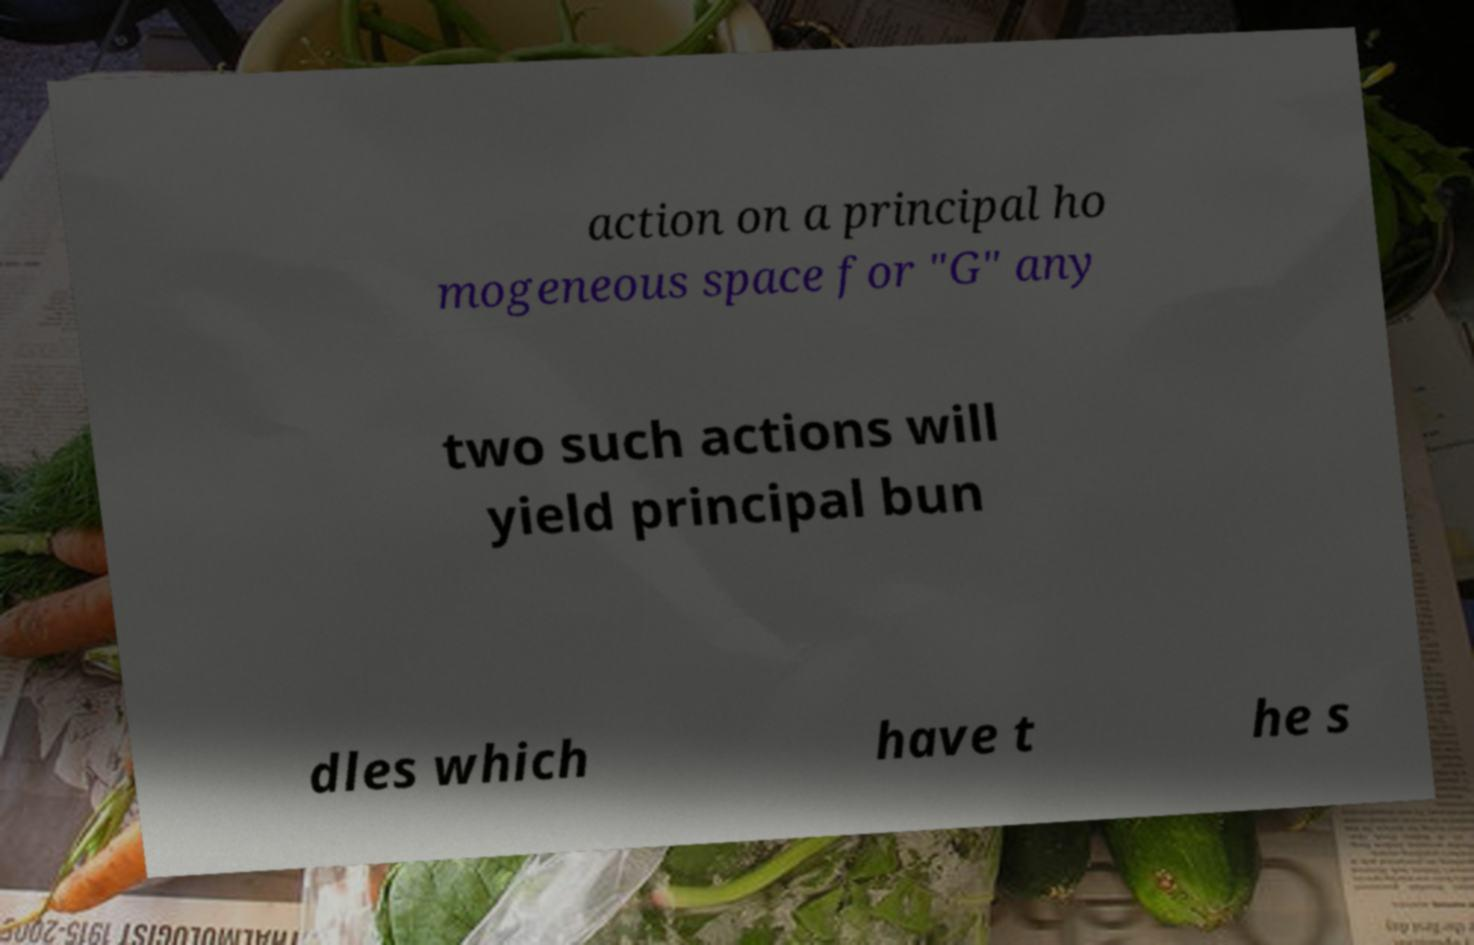There's text embedded in this image that I need extracted. Can you transcribe it verbatim? action on a principal ho mogeneous space for "G" any two such actions will yield principal bun dles which have t he s 